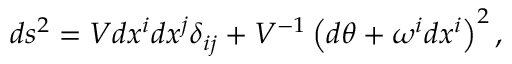Convert formula to latex. <formula><loc_0><loc_0><loc_500><loc_500>d s ^ { 2 } = V d x ^ { i } d x ^ { j } \delta _ { i j } + V ^ { - 1 } \left ( d \theta + \omega ^ { i } d x ^ { i } \right ) ^ { 2 } ,</formula> 